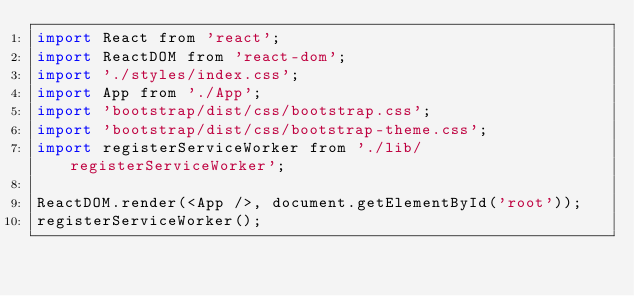Convert code to text. <code><loc_0><loc_0><loc_500><loc_500><_JavaScript_>import React from 'react';
import ReactDOM from 'react-dom';
import './styles/index.css';
import App from './App';
import 'bootstrap/dist/css/bootstrap.css';
import 'bootstrap/dist/css/bootstrap-theme.css';
import registerServiceWorker from './lib/registerServiceWorker';

ReactDOM.render(<App />, document.getElementById('root'));
registerServiceWorker();
</code> 